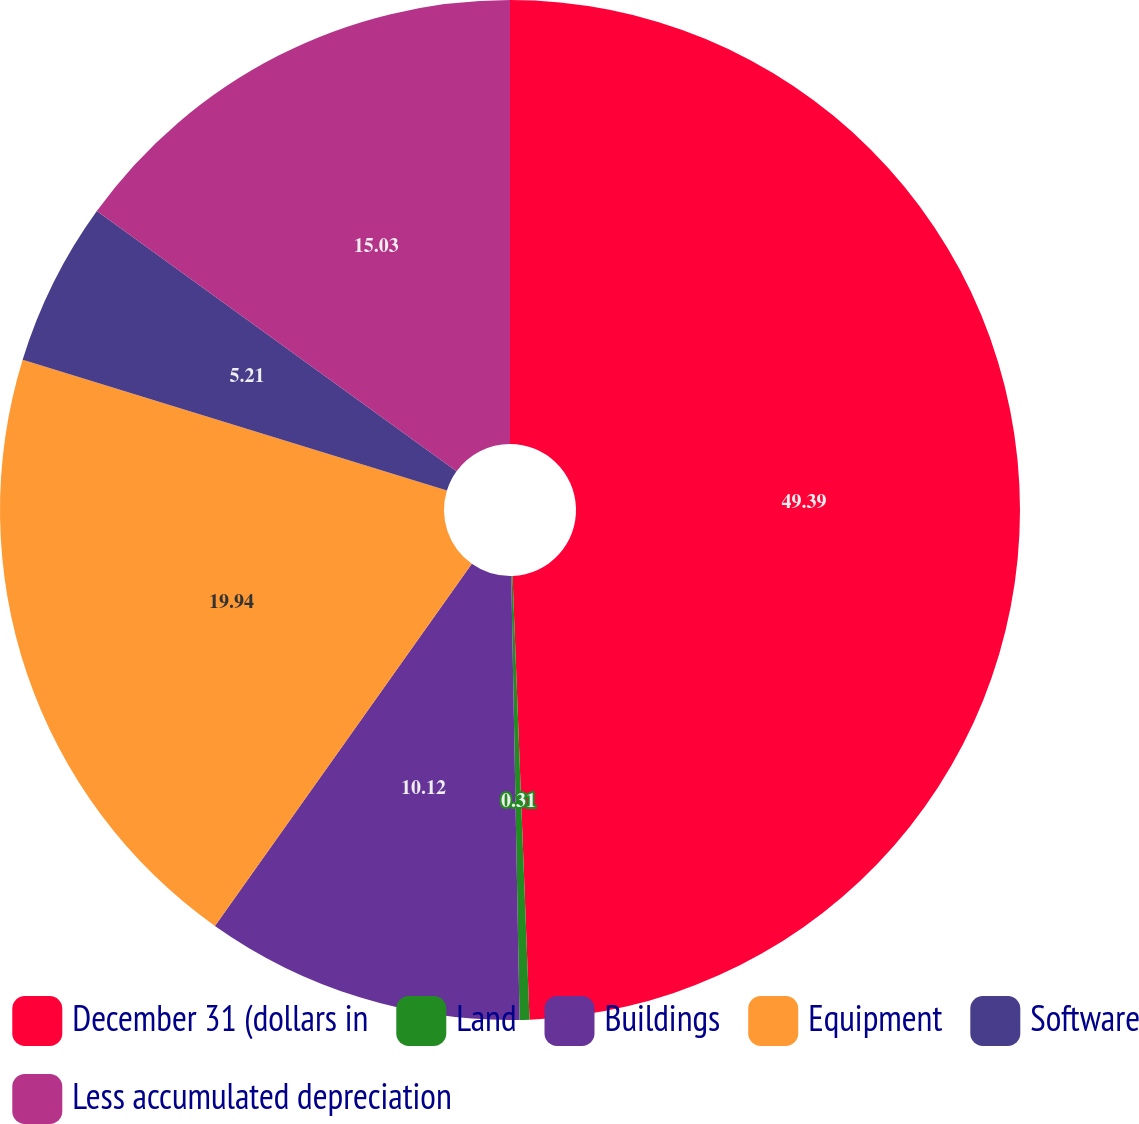Convert chart. <chart><loc_0><loc_0><loc_500><loc_500><pie_chart><fcel>December 31 (dollars in<fcel>Land<fcel>Buildings<fcel>Equipment<fcel>Software<fcel>Less accumulated depreciation<nl><fcel>49.39%<fcel>0.31%<fcel>10.12%<fcel>19.94%<fcel>5.21%<fcel>15.03%<nl></chart> 